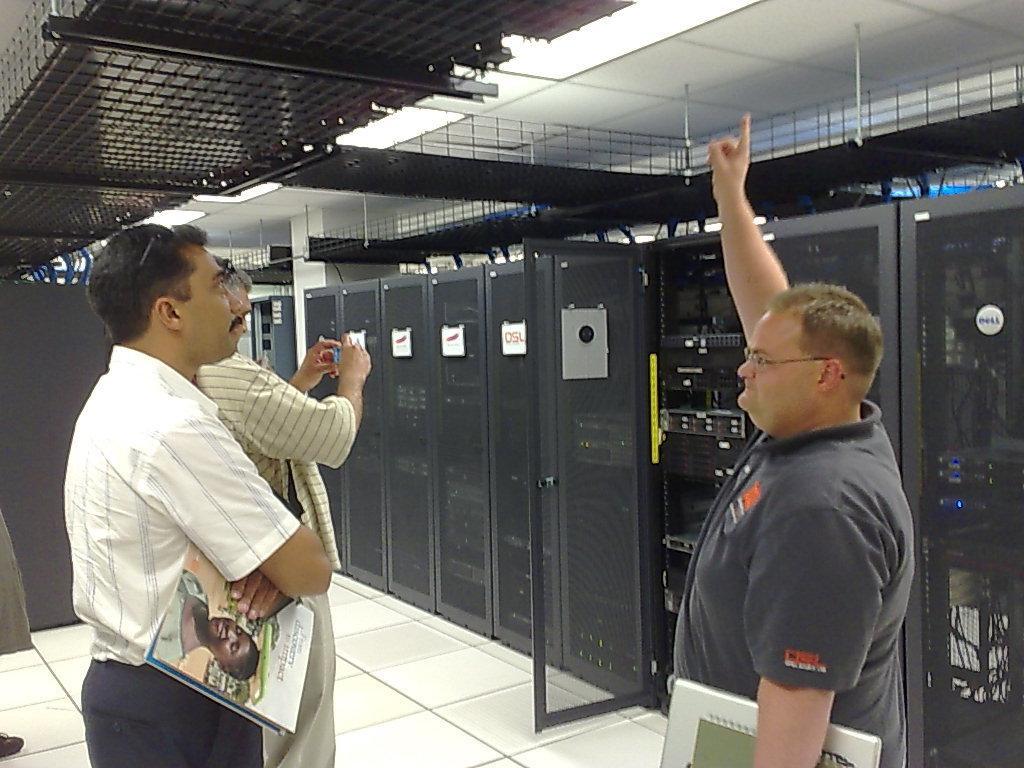How would you summarize this image in a sentence or two? This picture is inside view of a room. Here we can see some machines are there. On the right side of the image a man is standing and holding a books on his hand. On the left side of the image two persons are standing and holding a books and camera on there hands. At the top of the image roof is there. At the bottom of the image floor is present. 